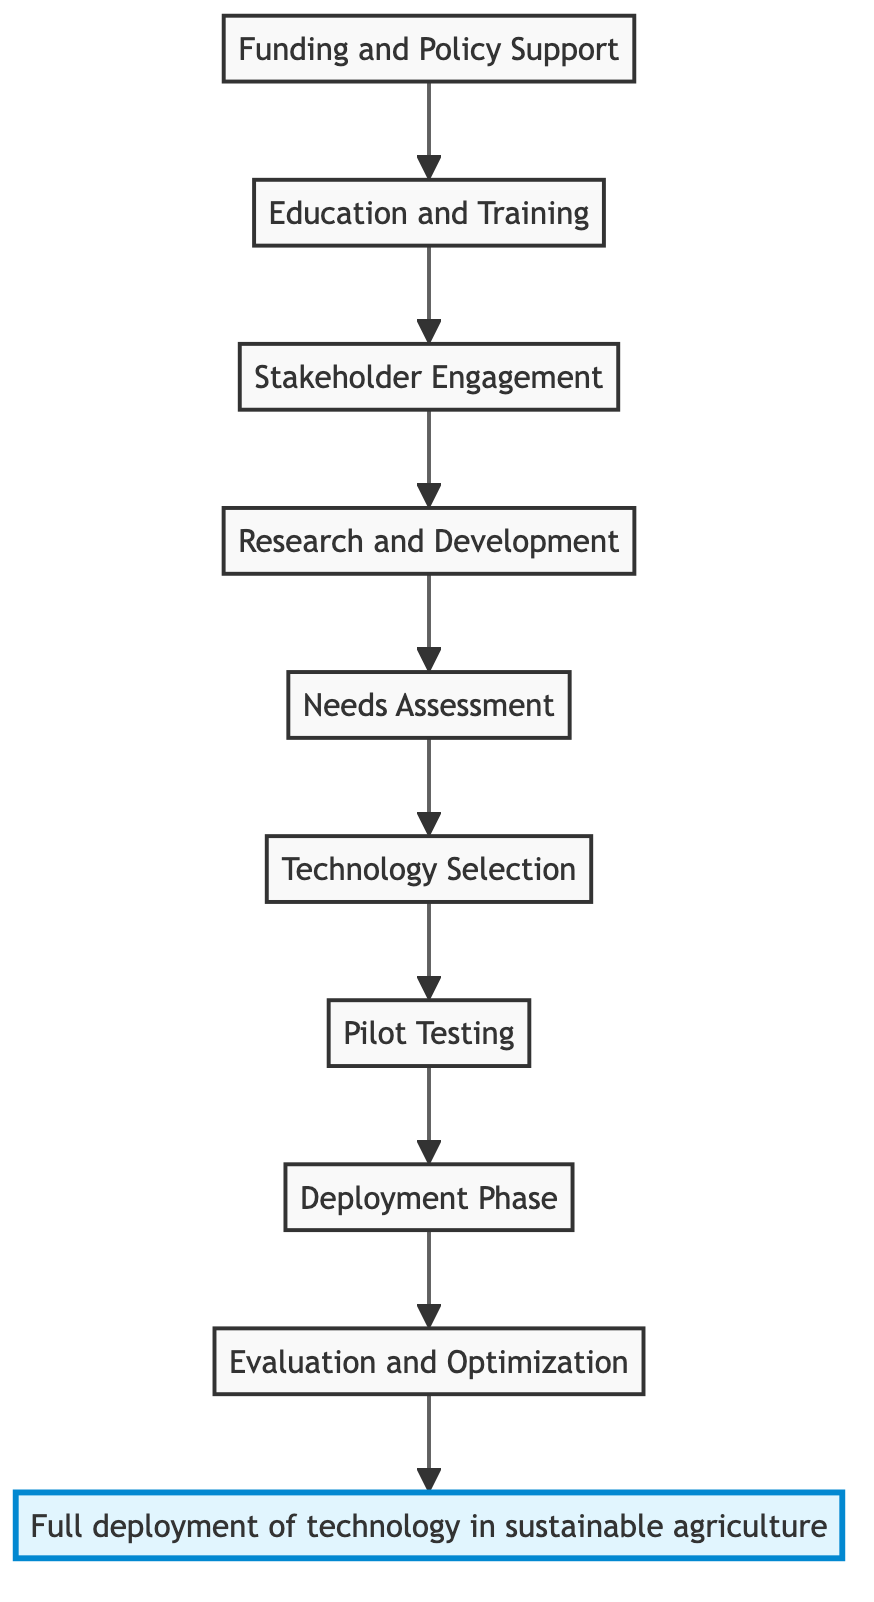What is the end goal of this flow chart? The end goal is represented at the top of the flow chart and is labeled "Full deployment of technology in sustainable agriculture." This goal is the final outcome intended from the entire process depicted in the flow chart.
Answer: Full deployment of technology in sustainable agriculture How many nodes are present in the diagram? To find the number of nodes, we can count each distinct step starting from "Funding and Policy Support" to "Full deployment of technology in sustainable agriculture." There are a total of 10 nodes in the flow chart.
Answer: 10 Which phase comes directly after "Pilot Testing"? Following the node labeled "Pilot Testing," the next stage in the flow chart is "Deployment Phase." This relationship is indicated by a direct arrow connecting the two phases.
Answer: Deployment Phase What is the first step in the flow to achieve full deployment? The flow starts with "Funding and Policy Support," which is the first step that initiates the entire process leading to full deployment of technology.
Answer: Funding and Policy Support What is the relationship between "Needs Assessment" and "Technology Selection"? "Needs Assessment" is the preceding step, and from it, there is a direct arrow leading to "Technology Selection." This indicates that the selection of technology is based on the identified needs and challenges.
Answer: Needs Assessment leads to Technology Selection How many steps are between "Education and Training" and the end goal? To find the number of steps between "Education and Training" and the end goal, we count the nodes from "Education and Training" up to "Full deployment of technology in sustainable agriculture." There are 6 steps in total.
Answer: 6 What phase follows "Stakeholder Engagement"? The phase that comes immediately after "Stakeholder Engagement" is "Research and Development." This sequence is shown in the flow chart with an arrow from one phase to the next.
Answer: Research and Development Which node includes securing funding for technology? The node that specifically addresses securing funding is labeled "Funding and Policy Support," and it is the first step in the process flow.
Answer: Funding and Policy Support What is the last step before "Full deployment of technology in sustainable agriculture"? The last step immediately preceding the end goal is "Evaluation and Optimization." This node assesses and optimizes the technology deployed before achieving full deployment.
Answer: Evaluation and Optimization 